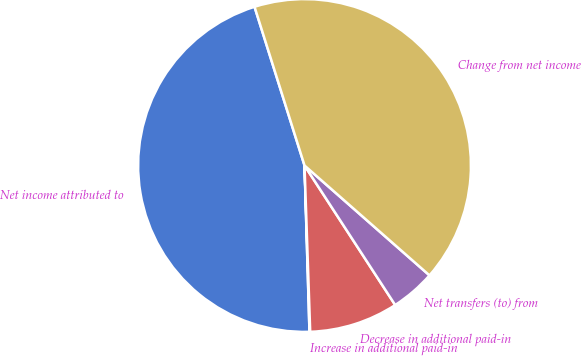Convert chart. <chart><loc_0><loc_0><loc_500><loc_500><pie_chart><fcel>Net income attributed to<fcel>Increase in additional paid-in<fcel>Decrease in additional paid-in<fcel>Net transfers (to) from<fcel>Change from net income<nl><fcel>45.62%<fcel>0.07%<fcel>8.63%<fcel>4.35%<fcel>41.34%<nl></chart> 